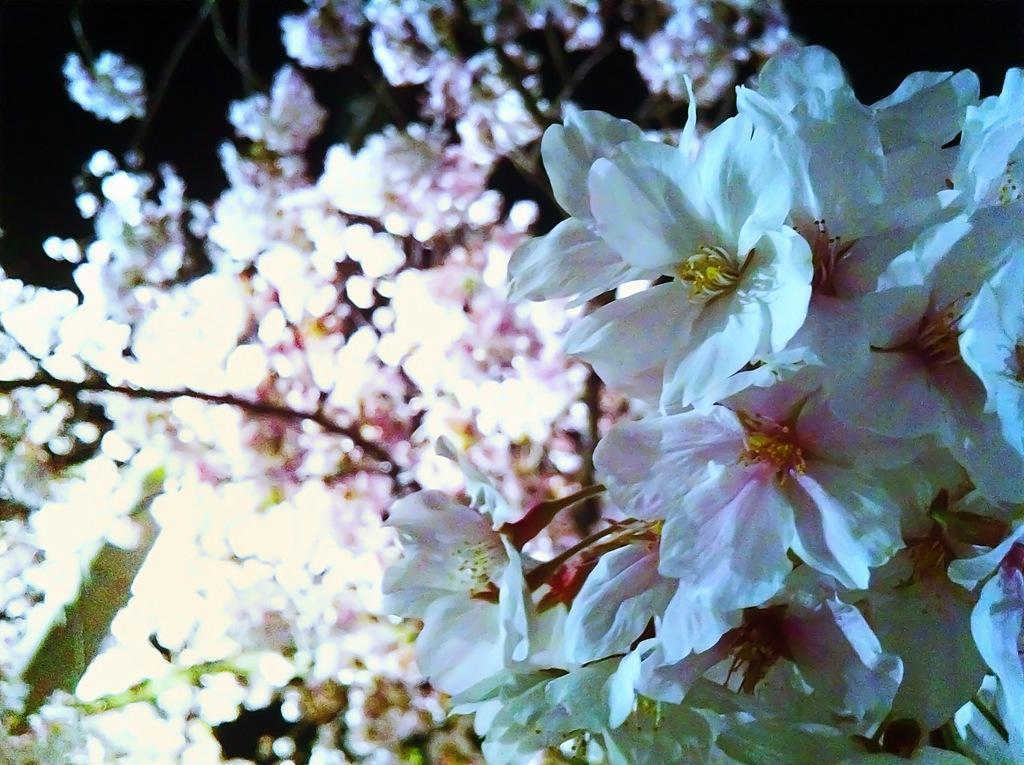Can you describe this image briefly? In this image there are few plants having flowers to it. Flowers are white in color. 